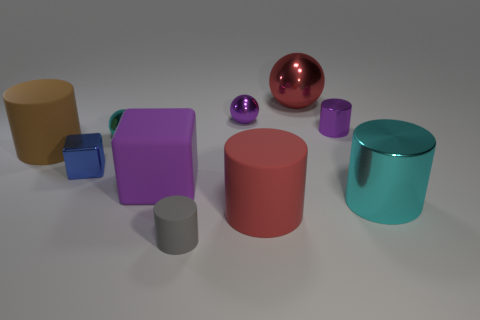Subtract all large brown cylinders. How many cylinders are left? 4 Subtract all cyan cylinders. How many cylinders are left? 4 Subtract 1 spheres. How many spheres are left? 2 Subtract all blocks. How many objects are left? 8 Subtract all metallic cylinders. Subtract all green matte objects. How many objects are left? 8 Add 1 big purple rubber blocks. How many big purple rubber blocks are left? 2 Add 7 brown things. How many brown things exist? 8 Subtract 0 green balls. How many objects are left? 10 Subtract all purple cylinders. Subtract all gray cubes. How many cylinders are left? 4 